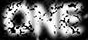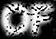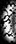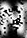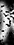What words can you see in these images in sequence, separated by a semicolon? ONE; OF; (; N; ) 